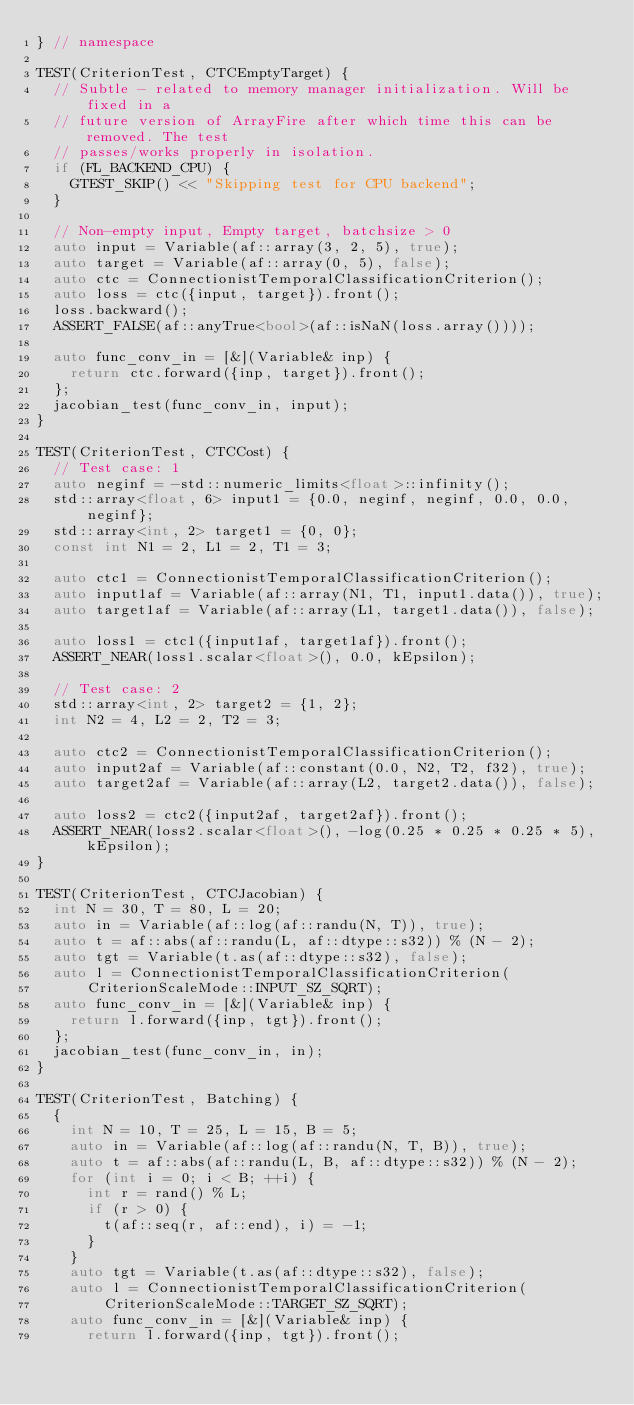Convert code to text. <code><loc_0><loc_0><loc_500><loc_500><_C++_>} // namespace

TEST(CriterionTest, CTCEmptyTarget) {
  // Subtle - related to memory manager initialization. Will be fixed in a
  // future version of ArrayFire after which time this can be removed. The test
  // passes/works properly in isolation.
  if (FL_BACKEND_CPU) {
    GTEST_SKIP() << "Skipping test for CPU backend";
  }

  // Non-empty input, Empty target, batchsize > 0
  auto input = Variable(af::array(3, 2, 5), true);
  auto target = Variable(af::array(0, 5), false);
  auto ctc = ConnectionistTemporalClassificationCriterion();
  auto loss = ctc({input, target}).front();
  loss.backward();
  ASSERT_FALSE(af::anyTrue<bool>(af::isNaN(loss.array())));

  auto func_conv_in = [&](Variable& inp) {
    return ctc.forward({inp, target}).front();
  };
  jacobian_test(func_conv_in, input);
}

TEST(CriterionTest, CTCCost) {
  // Test case: 1
  auto neginf = -std::numeric_limits<float>::infinity();
  std::array<float, 6> input1 = {0.0, neginf, neginf, 0.0, 0.0, neginf};
  std::array<int, 2> target1 = {0, 0};
  const int N1 = 2, L1 = 2, T1 = 3;

  auto ctc1 = ConnectionistTemporalClassificationCriterion();
  auto input1af = Variable(af::array(N1, T1, input1.data()), true);
  auto target1af = Variable(af::array(L1, target1.data()), false);

  auto loss1 = ctc1({input1af, target1af}).front();
  ASSERT_NEAR(loss1.scalar<float>(), 0.0, kEpsilon);

  // Test case: 2
  std::array<int, 2> target2 = {1, 2};
  int N2 = 4, L2 = 2, T2 = 3;

  auto ctc2 = ConnectionistTemporalClassificationCriterion();
  auto input2af = Variable(af::constant(0.0, N2, T2, f32), true);
  auto target2af = Variable(af::array(L2, target2.data()), false);

  auto loss2 = ctc2({input2af, target2af}).front();
  ASSERT_NEAR(loss2.scalar<float>(), -log(0.25 * 0.25 * 0.25 * 5), kEpsilon);
}

TEST(CriterionTest, CTCJacobian) {
  int N = 30, T = 80, L = 20;
  auto in = Variable(af::log(af::randu(N, T)), true);
  auto t = af::abs(af::randu(L, af::dtype::s32)) % (N - 2);
  auto tgt = Variable(t.as(af::dtype::s32), false);
  auto l = ConnectionistTemporalClassificationCriterion(
      CriterionScaleMode::INPUT_SZ_SQRT);
  auto func_conv_in = [&](Variable& inp) {
    return l.forward({inp, tgt}).front();
  };
  jacobian_test(func_conv_in, in);
}

TEST(CriterionTest, Batching) {
  {
    int N = 10, T = 25, L = 15, B = 5;
    auto in = Variable(af::log(af::randu(N, T, B)), true);
    auto t = af::abs(af::randu(L, B, af::dtype::s32)) % (N - 2);
    for (int i = 0; i < B; ++i) {
      int r = rand() % L;
      if (r > 0) {
        t(af::seq(r, af::end), i) = -1;
      }
    }
    auto tgt = Variable(t.as(af::dtype::s32), false);
    auto l = ConnectionistTemporalClassificationCriterion(
        CriterionScaleMode::TARGET_SZ_SQRT);
    auto func_conv_in = [&](Variable& inp) {
      return l.forward({inp, tgt}).front();</code> 